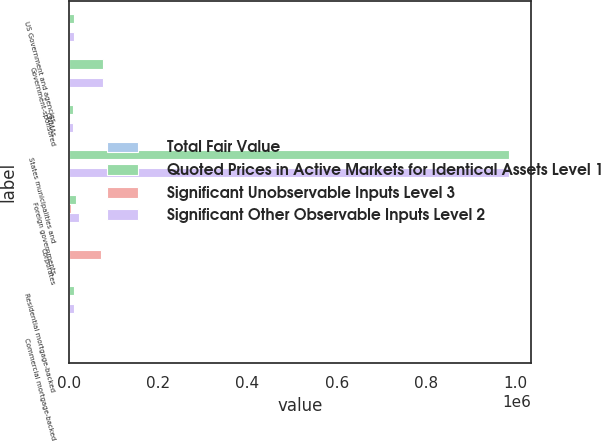Convert chart to OTSL. <chart><loc_0><loc_0><loc_500><loc_500><stacked_bar_chart><ecel><fcel>US Government and agencies<fcel>Government-sponsored<fcel>GNMAs<fcel>States municipalities and<fcel>Foreign governments<fcel>Corporates<fcel>Residential mortgage-backed<fcel>Commercial mortgage-backed<nl><fcel>Total Fair Value<fcel>0<fcel>0<fcel>0<fcel>0<fcel>0<fcel>0<fcel>0<fcel>0<nl><fcel>Quoted Prices in Active Markets for Identical Assets Level 1<fcel>12495<fcel>77519<fcel>8897<fcel>986462<fcel>16618<fcel>1626<fcel>11111<fcel>1626<nl><fcel>Significant Unobservable Inputs Level 3<fcel>0<fcel>0<fcel>0<fcel>0<fcel>5196<fcel>71764<fcel>0<fcel>0<nl><fcel>Significant Other Observable Inputs Level 2<fcel>12495<fcel>77519<fcel>8897<fcel>986462<fcel>21814<fcel>1626<fcel>11111<fcel>1626<nl></chart> 